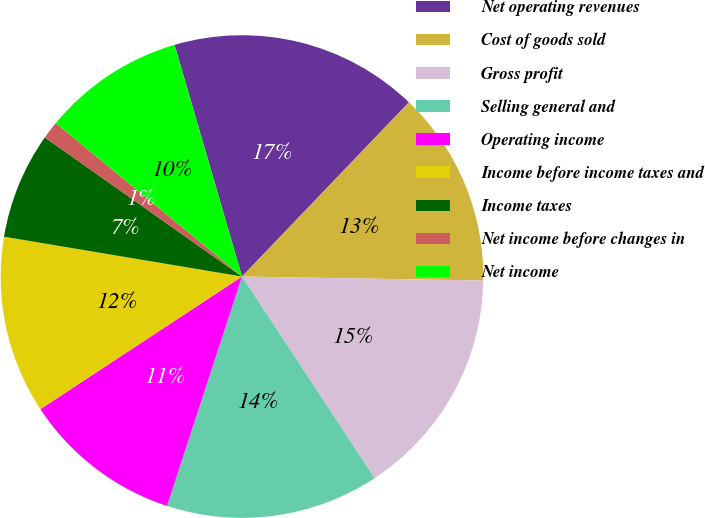Convert chart to OTSL. <chart><loc_0><loc_0><loc_500><loc_500><pie_chart><fcel>Net operating revenues<fcel>Cost of goods sold<fcel>Gross profit<fcel>Selling general and<fcel>Operating income<fcel>Income before income taxes and<fcel>Income taxes<fcel>Net income before changes in<fcel>Net income<nl><fcel>16.67%<fcel>13.1%<fcel>15.48%<fcel>14.29%<fcel>10.71%<fcel>11.9%<fcel>7.14%<fcel>1.19%<fcel>9.52%<nl></chart> 